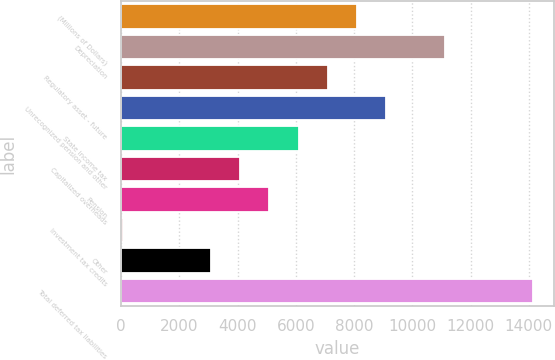<chart> <loc_0><loc_0><loc_500><loc_500><bar_chart><fcel>(Millions of Dollars)<fcel>Depreciation<fcel>Regulatory asset - future<fcel>Unrecognized pension and other<fcel>State income tax<fcel>Capitalized overheads<fcel>Pension<fcel>Investment tax credits<fcel>Other<fcel>Total deferred tax liabilities<nl><fcel>8105.6<fcel>11125.7<fcel>7098.9<fcel>9112.3<fcel>6092.2<fcel>4078.8<fcel>5085.5<fcel>52<fcel>3072.1<fcel>14145.8<nl></chart> 